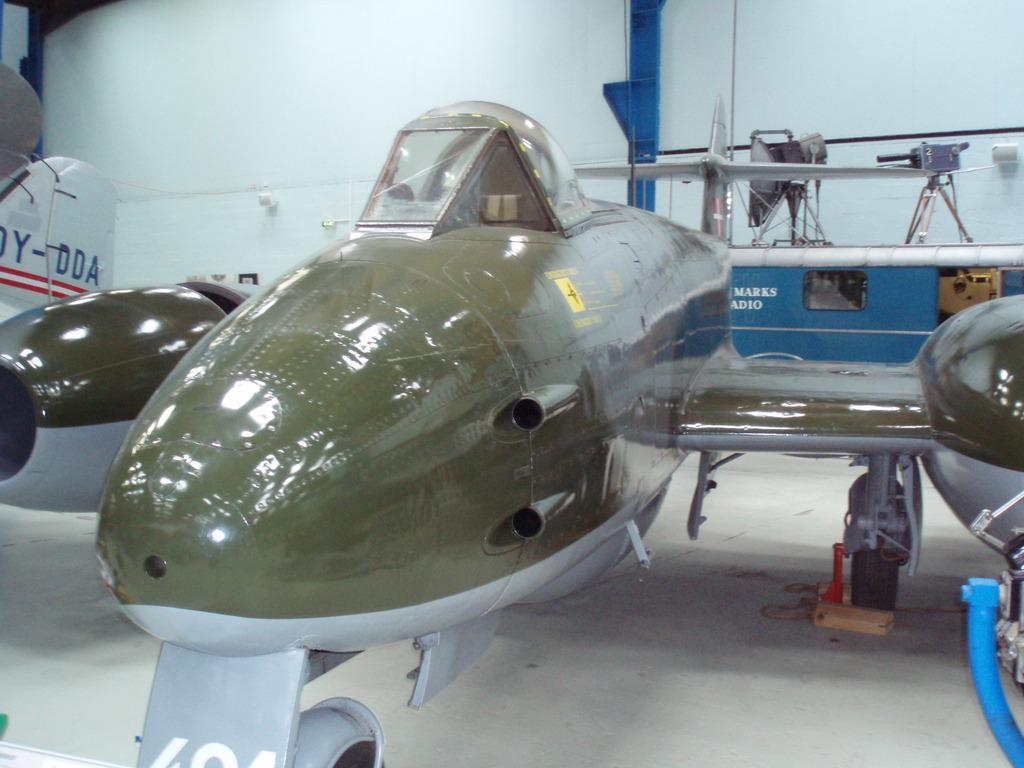<image>
Describe the image concisely. a plane with some numbers at the bottom of it 